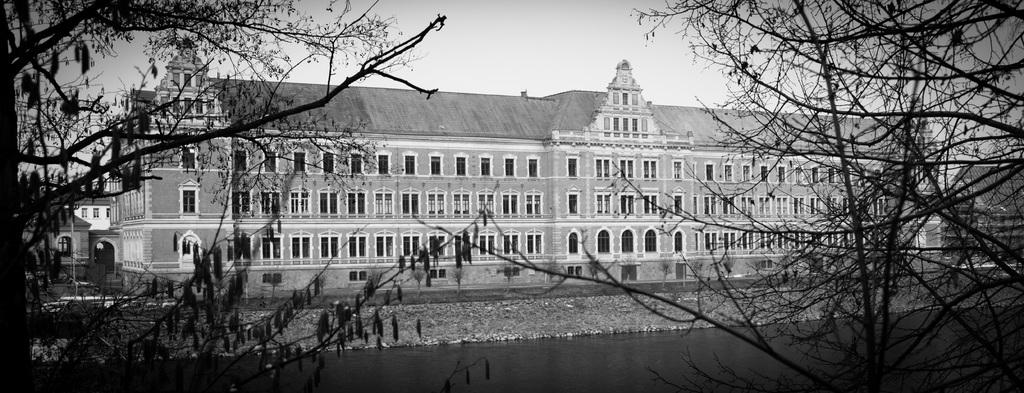What type of structure is present in the image? There is a building in the image. What natural feature can be seen in the image? There is a lake in the image. What type of vegetation is visible in the image? There are trees in the image. Can you tell me how many letters are floating on the lake in the image? There are no letters floating on the lake in the image. Did the building experience any damage due to an earthquake in the image? There is no indication of an earthquake or any damage to the building in the image. 